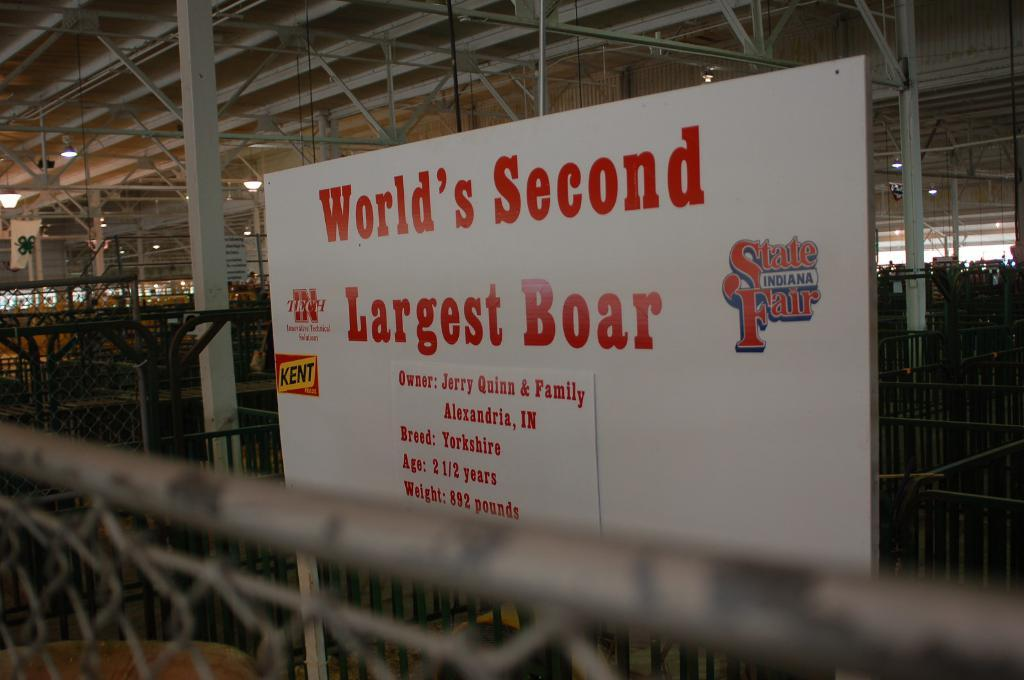<image>
Present a compact description of the photo's key features. A sign reads "World's Second Largest Boar" at the Indiana State Fair. 